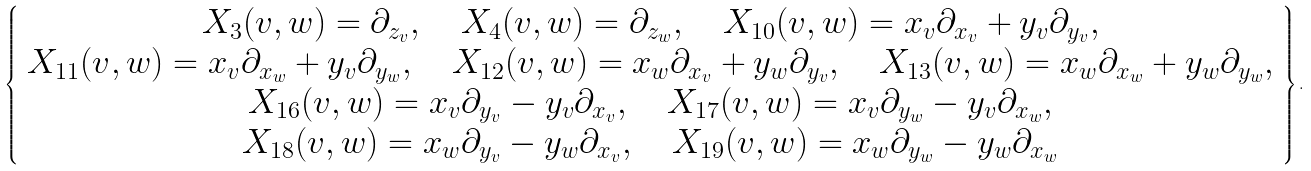<formula> <loc_0><loc_0><loc_500><loc_500>\left \{ \begin{array} { c } X _ { 3 } ( v , w ) = \partial _ { z _ { v } } , \quad X _ { 4 } ( v , w ) = \partial _ { z _ { w } } , \quad X _ { 1 0 } ( v , w ) = x _ { v } \partial _ { x _ { v } } + y _ { v } \partial _ { y _ { v } } , \\ X _ { 1 1 } ( v , w ) = x _ { v } \partial _ { x _ { w } } + y _ { v } \partial _ { y _ { w } } , \quad X _ { 1 2 } ( v , w ) = x _ { w } \partial _ { x _ { v } } + y _ { w } \partial _ { y _ { v } } , \quad X _ { 1 3 } ( v , w ) = x _ { w } \partial _ { x _ { w } } + y _ { w } \partial _ { y _ { w } } , \\ X _ { 1 6 } ( v , w ) = x _ { v } \partial _ { y _ { v } } - y _ { v } \partial _ { x _ { v } } , \quad X _ { 1 7 } ( v , w ) = x _ { v } \partial _ { y _ { w } } - y _ { v } \partial _ { x _ { w } } , \\ X _ { 1 8 } ( v , w ) = x _ { w } \partial _ { y _ { v } } - y _ { w } \partial _ { x _ { v } } , \quad X _ { 1 9 } ( v , w ) = x _ { w } \partial _ { y _ { w } } - y _ { w } \partial _ { x _ { w } } \end{array} \right \} .</formula> 